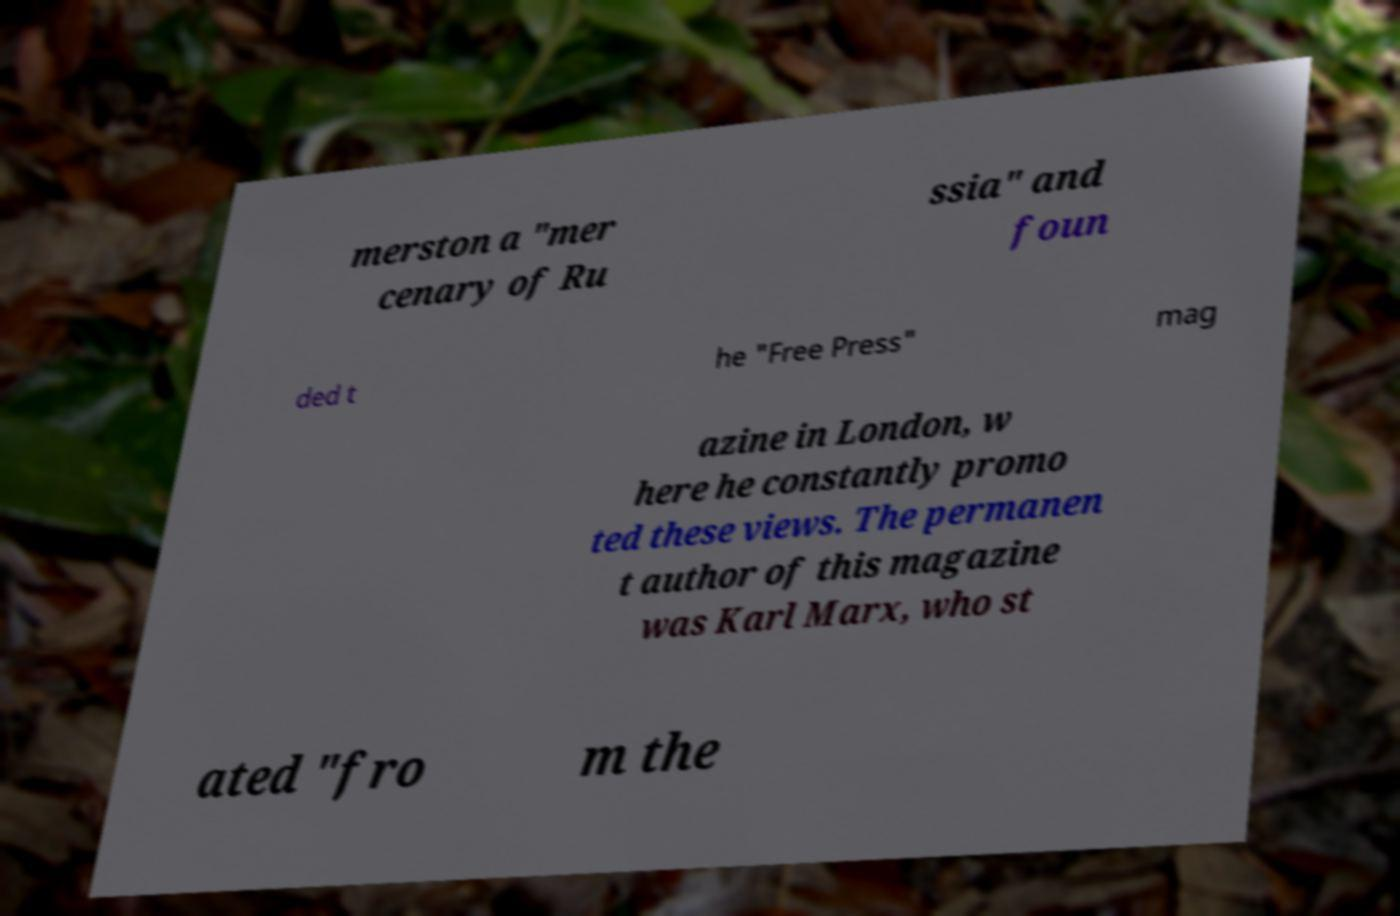Please read and relay the text visible in this image. What does it say? merston a "mer cenary of Ru ssia" and foun ded t he "Free Press" mag azine in London, w here he constantly promo ted these views. The permanen t author of this magazine was Karl Marx, who st ated "fro m the 